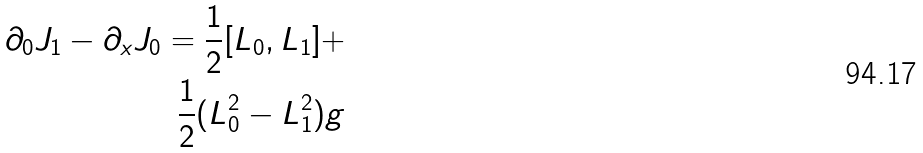Convert formula to latex. <formula><loc_0><loc_0><loc_500><loc_500>\partial _ { 0 } J _ { 1 } - \partial _ { x } J _ { 0 } = \frac { 1 } { 2 } [ L _ { 0 } , L _ { 1 } ] + \\ \frac { 1 } { 2 } ( L _ { 0 } ^ { 2 } - L _ { 1 } ^ { 2 } ) g</formula> 